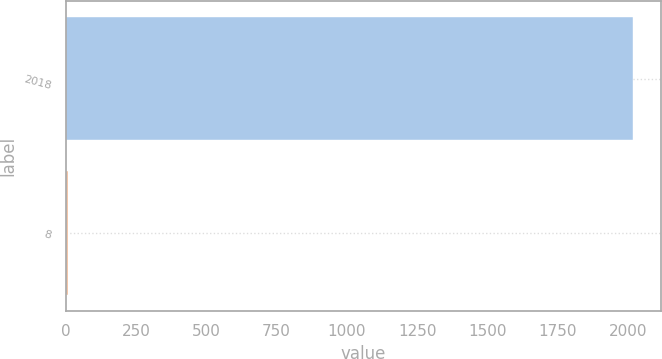Convert chart. <chart><loc_0><loc_0><loc_500><loc_500><bar_chart><fcel>2018<fcel>8<nl><fcel>2018<fcel>9<nl></chart> 